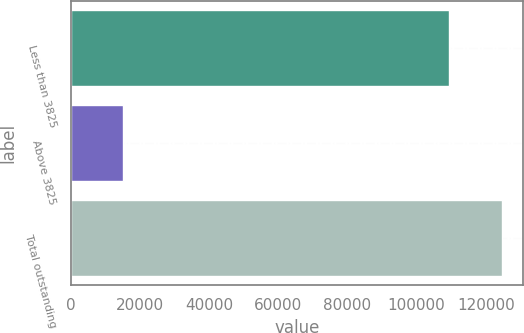<chart> <loc_0><loc_0><loc_500><loc_500><bar_chart><fcel>Less than 3825<fcel>Above 3825<fcel>Total outstanding<nl><fcel>109448<fcel>15202<fcel>124650<nl></chart> 